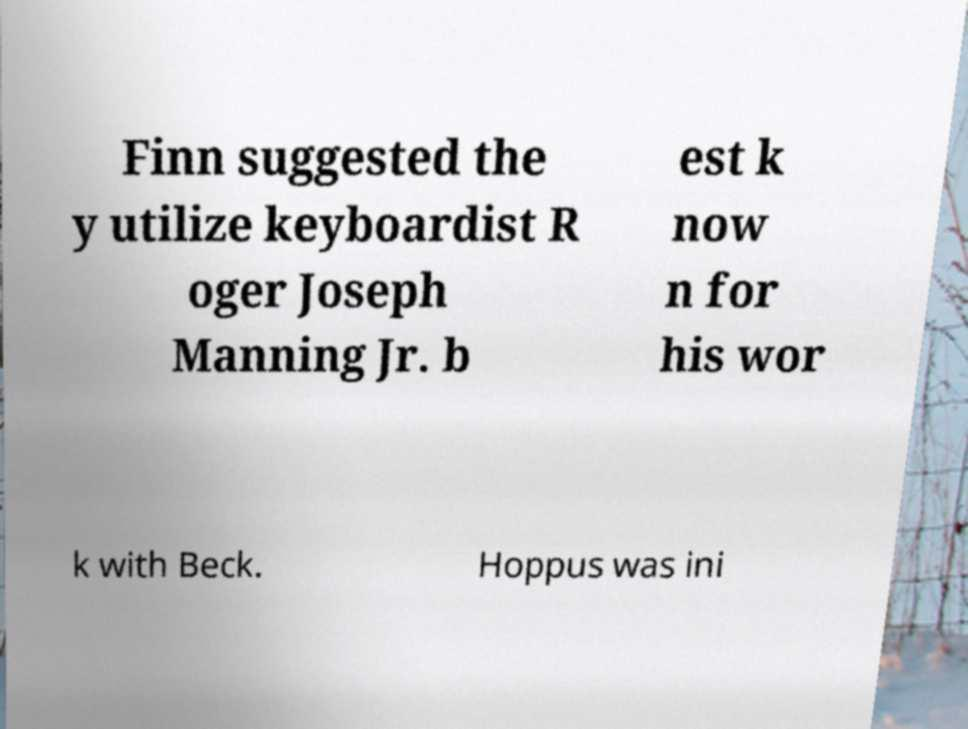I need the written content from this picture converted into text. Can you do that? Finn suggested the y utilize keyboardist R oger Joseph Manning Jr. b est k now n for his wor k with Beck. Hoppus was ini 